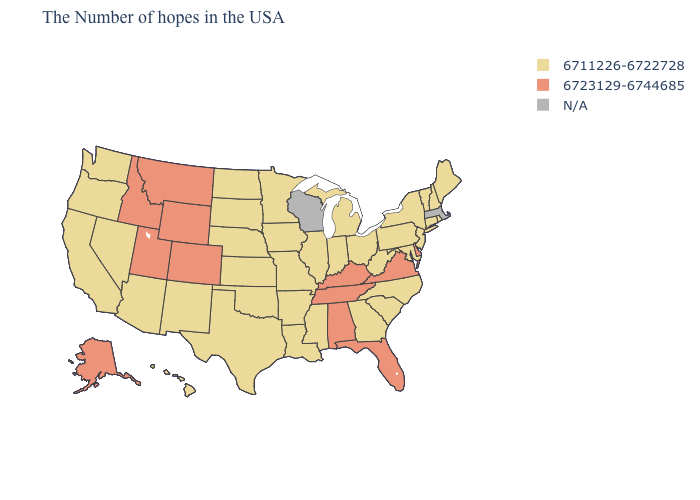What is the highest value in states that border Vermont?
Be succinct. 6711226-6722728. Among the states that border South Carolina , which have the lowest value?
Keep it brief. North Carolina, Georgia. Name the states that have a value in the range 6711226-6722728?
Concise answer only. Maine, Rhode Island, New Hampshire, Vermont, Connecticut, New York, New Jersey, Maryland, Pennsylvania, North Carolina, South Carolina, West Virginia, Ohio, Georgia, Michigan, Indiana, Illinois, Mississippi, Louisiana, Missouri, Arkansas, Minnesota, Iowa, Kansas, Nebraska, Oklahoma, Texas, South Dakota, North Dakota, New Mexico, Arizona, Nevada, California, Washington, Oregon, Hawaii. What is the lowest value in the USA?
Write a very short answer. 6711226-6722728. Among the states that border Minnesota , which have the highest value?
Give a very brief answer. Iowa, South Dakota, North Dakota. Name the states that have a value in the range N/A?
Answer briefly. Massachusetts, Wisconsin. Among the states that border West Virginia , does Maryland have the lowest value?
Short answer required. Yes. Does Alaska have the lowest value in the USA?
Concise answer only. No. What is the lowest value in the West?
Write a very short answer. 6711226-6722728. Does the map have missing data?
Answer briefly. Yes. Does the first symbol in the legend represent the smallest category?
Write a very short answer. Yes. Among the states that border New Mexico , does Texas have the highest value?
Concise answer only. No. Which states have the highest value in the USA?
Quick response, please. Delaware, Virginia, Florida, Kentucky, Alabama, Tennessee, Wyoming, Colorado, Utah, Montana, Idaho, Alaska. Name the states that have a value in the range 6723129-6744685?
Keep it brief. Delaware, Virginia, Florida, Kentucky, Alabama, Tennessee, Wyoming, Colorado, Utah, Montana, Idaho, Alaska. 